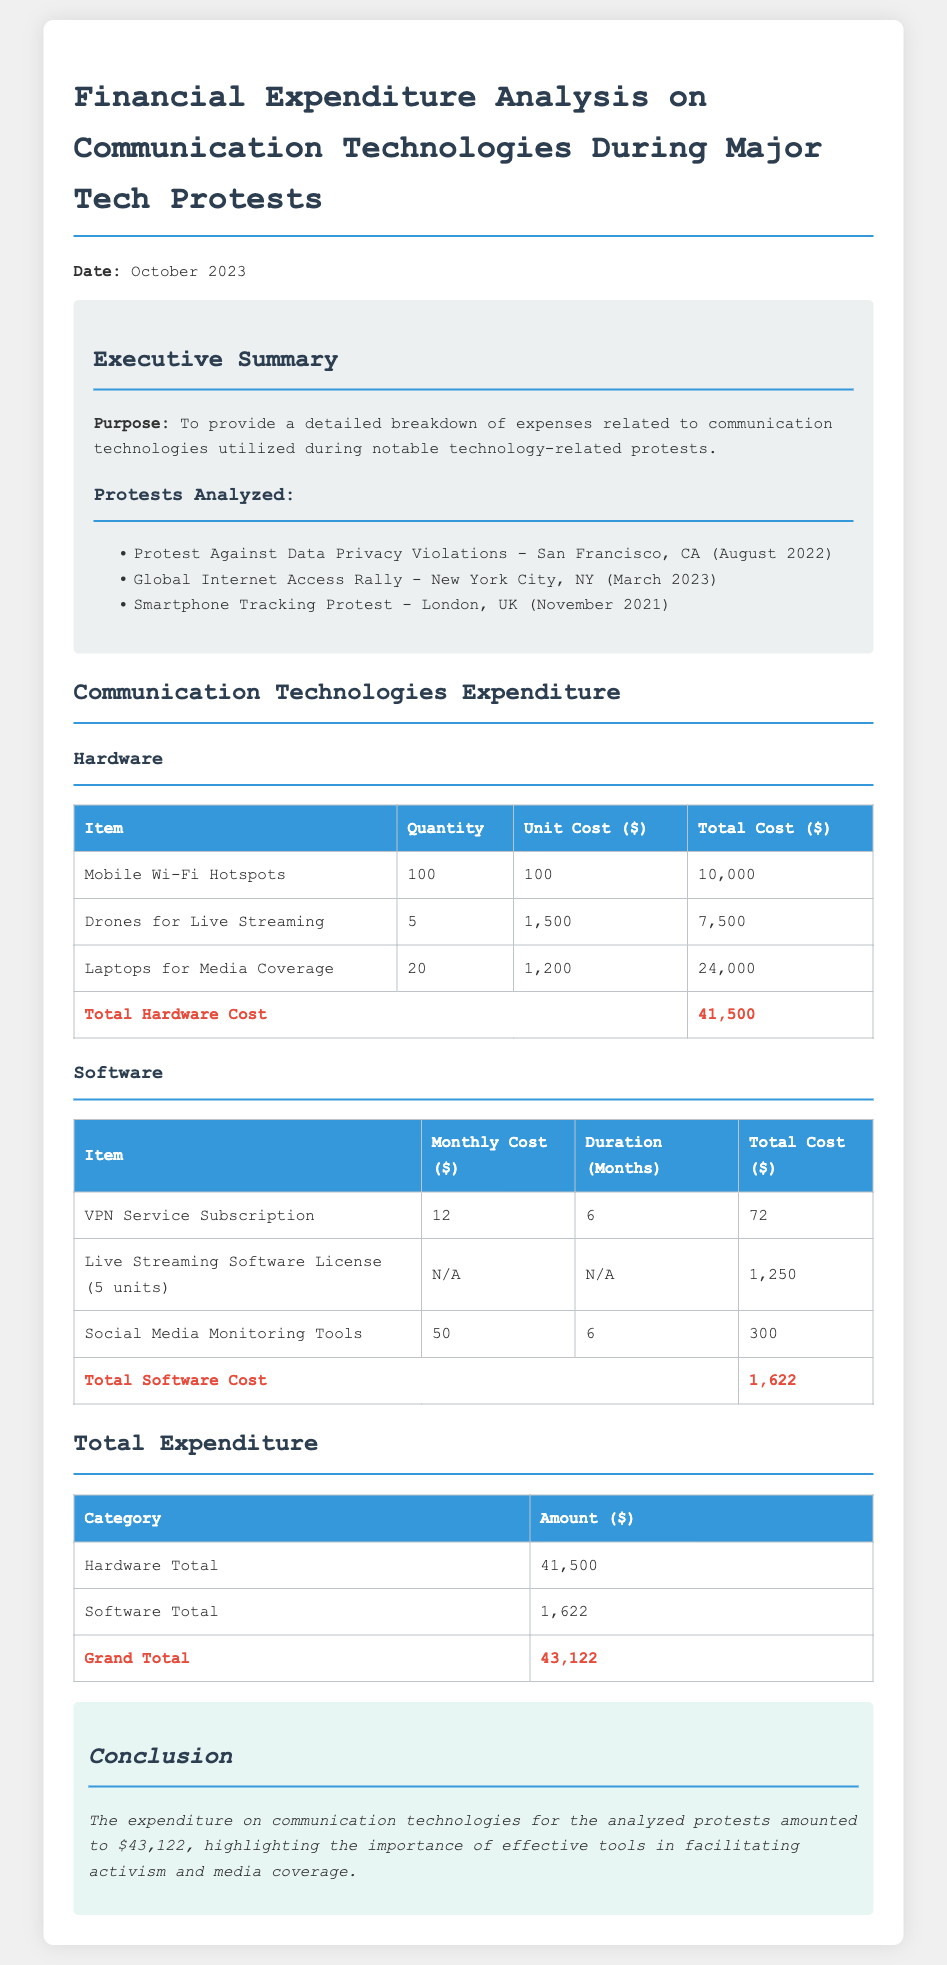What is the total hardware cost? The total hardware cost is summed up from the individual hardware item costs which total $41,500.
Answer: $41,500 What is the total software cost? The total software cost is derived from the software expenses in the document, totaling $1,622.
Answer: $1,622 What is the grand total expenditure? The grand total is the sum of total hardware and software costs amounting to $43,122.
Answer: $43,122 Which protest occurred in March 2023? The document lists the protests analyzed, highlighting the Global Internet Access Rally as the event in March 2023.
Answer: Global Internet Access Rally How many laptops were purchased for media coverage? The quantity listed for laptops used for media coverage is 20, as shown in the hardware table.
Answer: 20 What is the monthly cost of the VPN service subscription? The document specifies the monthly cost for the VPN service subscription as $12.
Answer: $12 How much did the live streaming software license cost in total? The total cost for the live streaming software license is explicitly given as $1,250 in the software table.
Answer: $1,250 What was the duration of the social media monitoring tools subscription? The duration for the social media monitoring tools subscription is indicated as 6 months in the software section.
Answer: 6 months What is the purpose of this financial report? The purpose is summarized in the executive summary stating it provides a breakdown of communication technology expenses during protests.
Answer: To provide a detailed breakdown of expenses related to communication technologies utilized during notable technology-related protests 